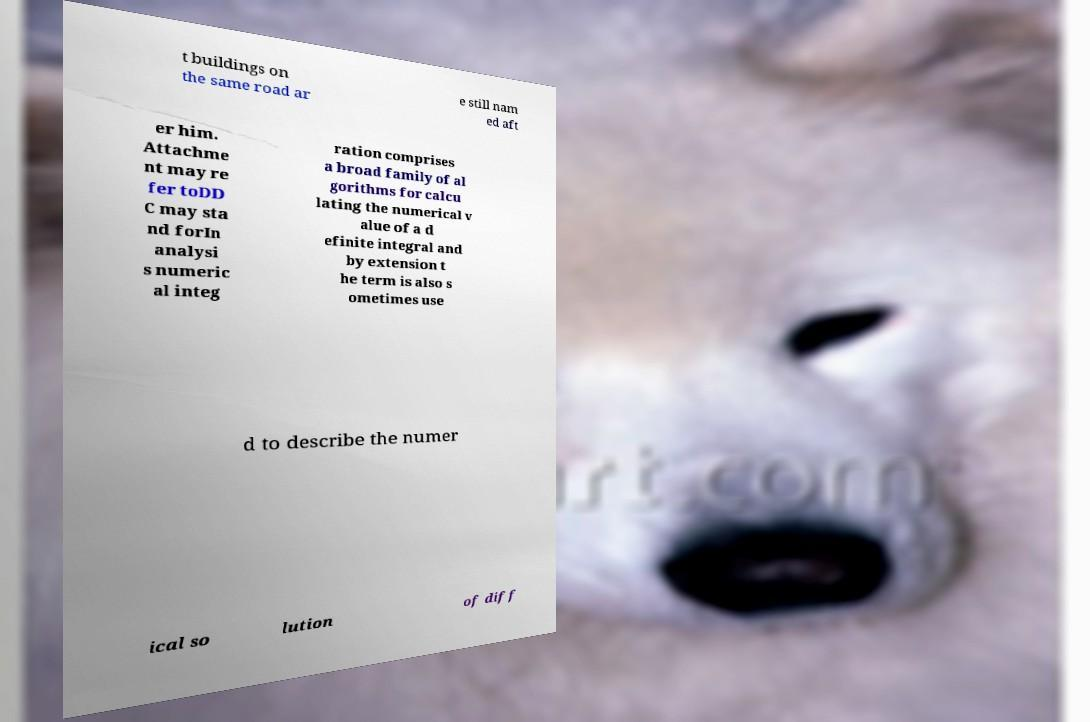Could you extract and type out the text from this image? t buildings on the same road ar e still nam ed aft er him. Attachme nt may re fer toDD C may sta nd forIn analysi s numeric al integ ration comprises a broad family of al gorithms for calcu lating the numerical v alue of a d efinite integral and by extension t he term is also s ometimes use d to describe the numer ical so lution of diff 